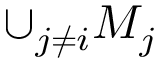Convert formula to latex. <formula><loc_0><loc_0><loc_500><loc_500>\cup _ { j \neq i } M _ { j }</formula> 